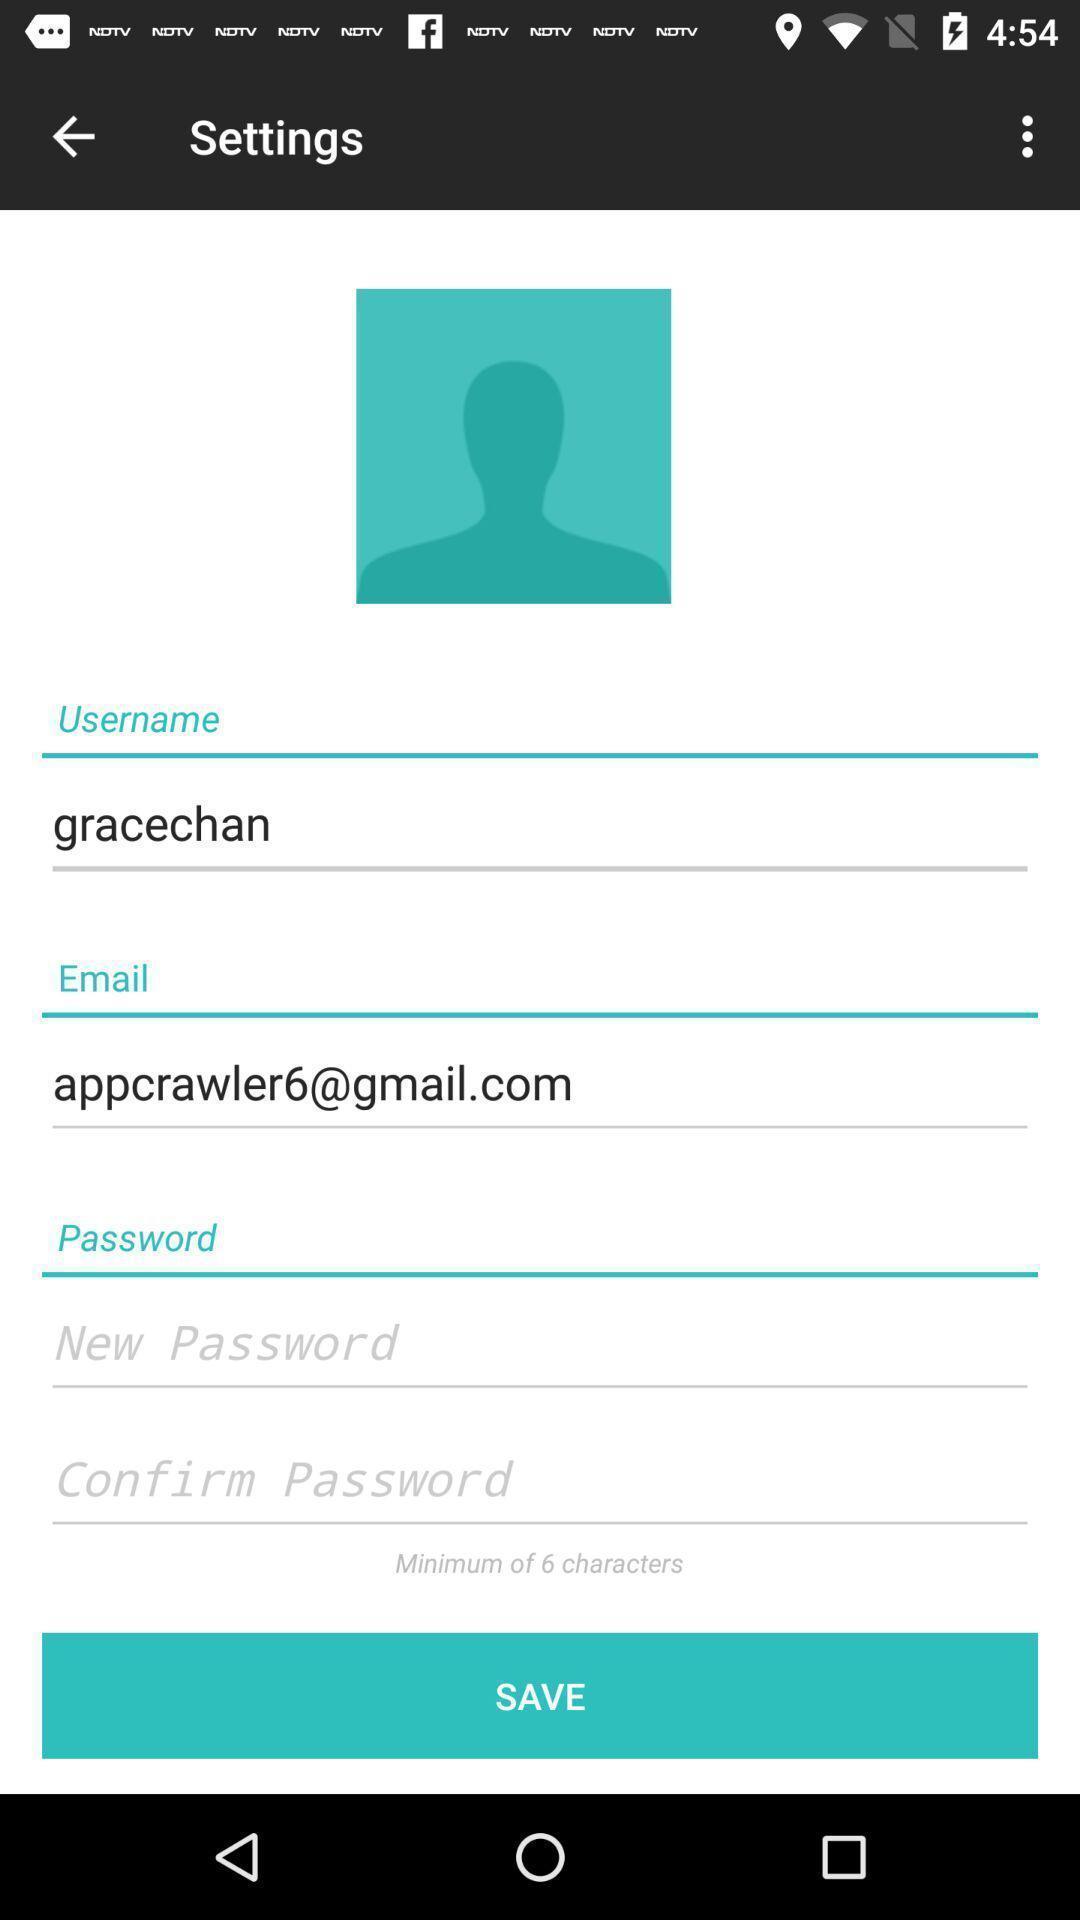Describe this image in words. Settings page. 